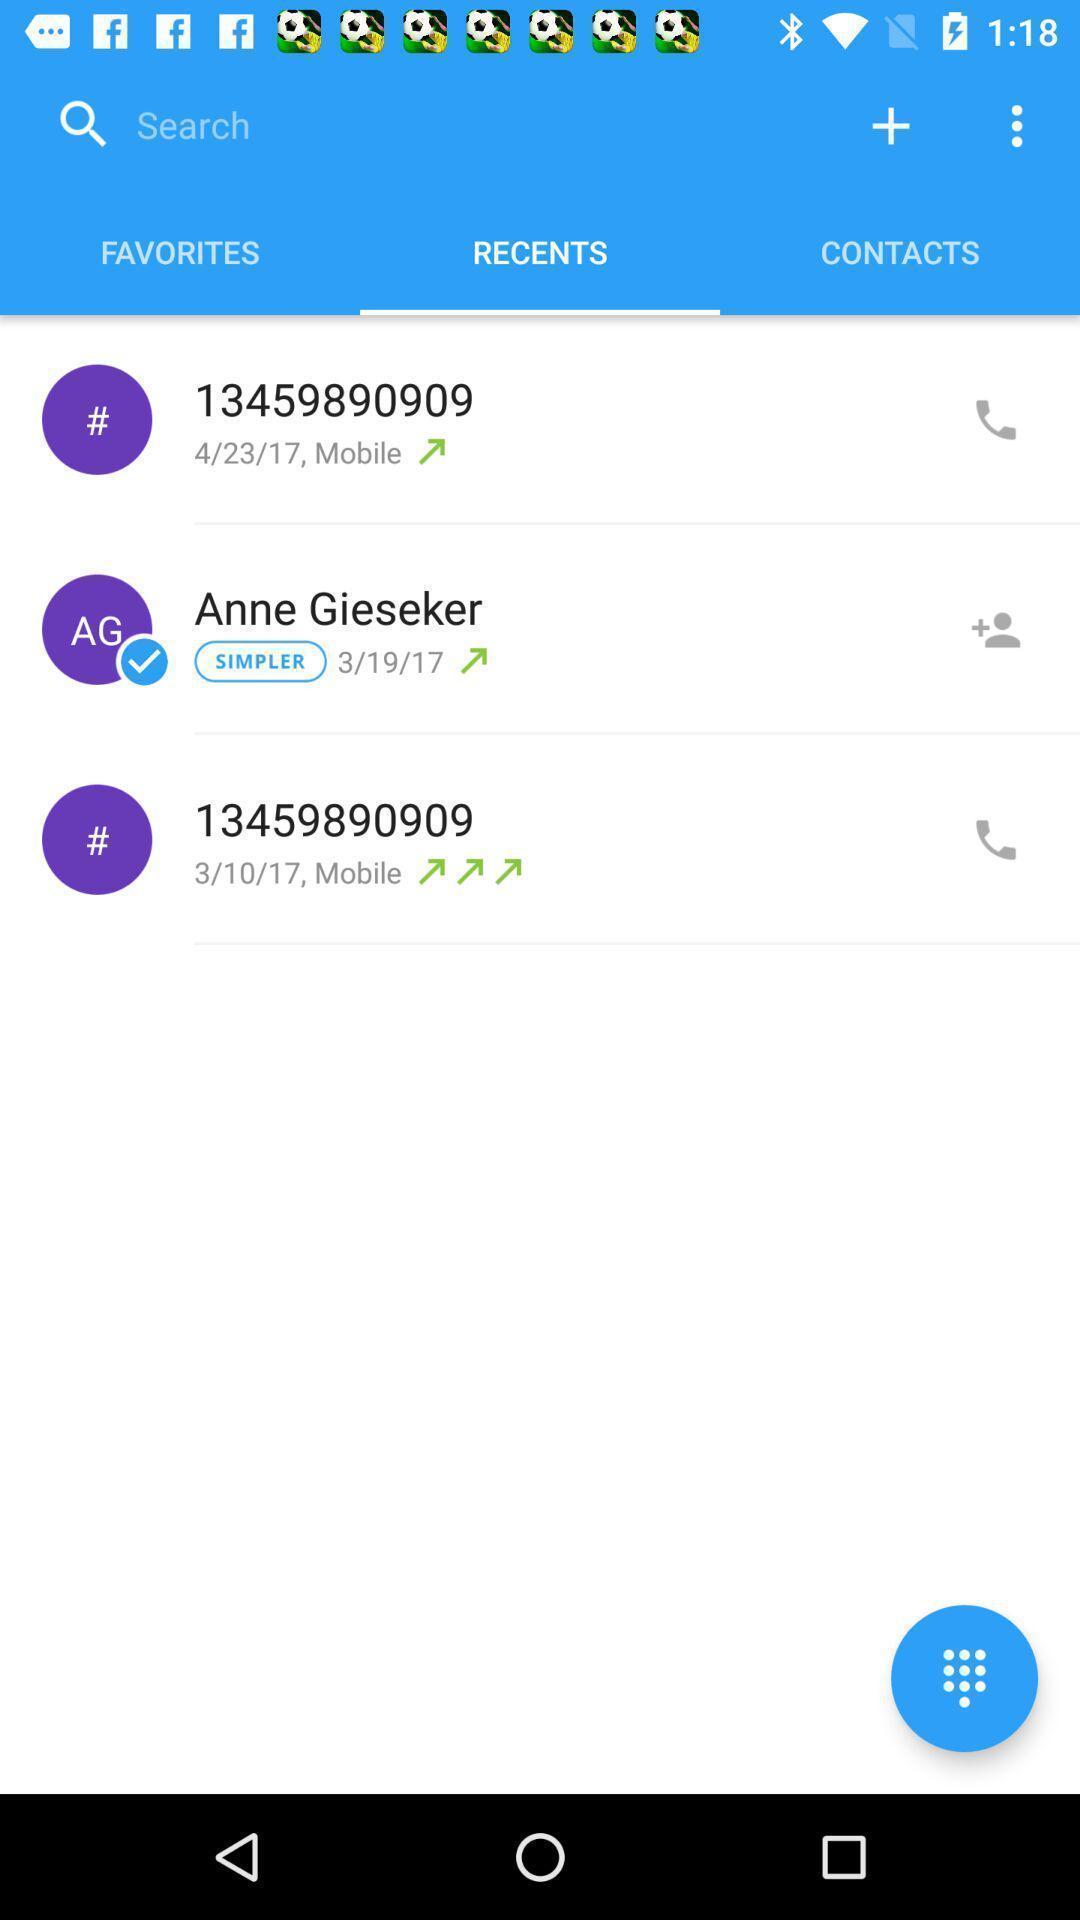What details can you identify in this image? Three instances are displaying in recent call details. 